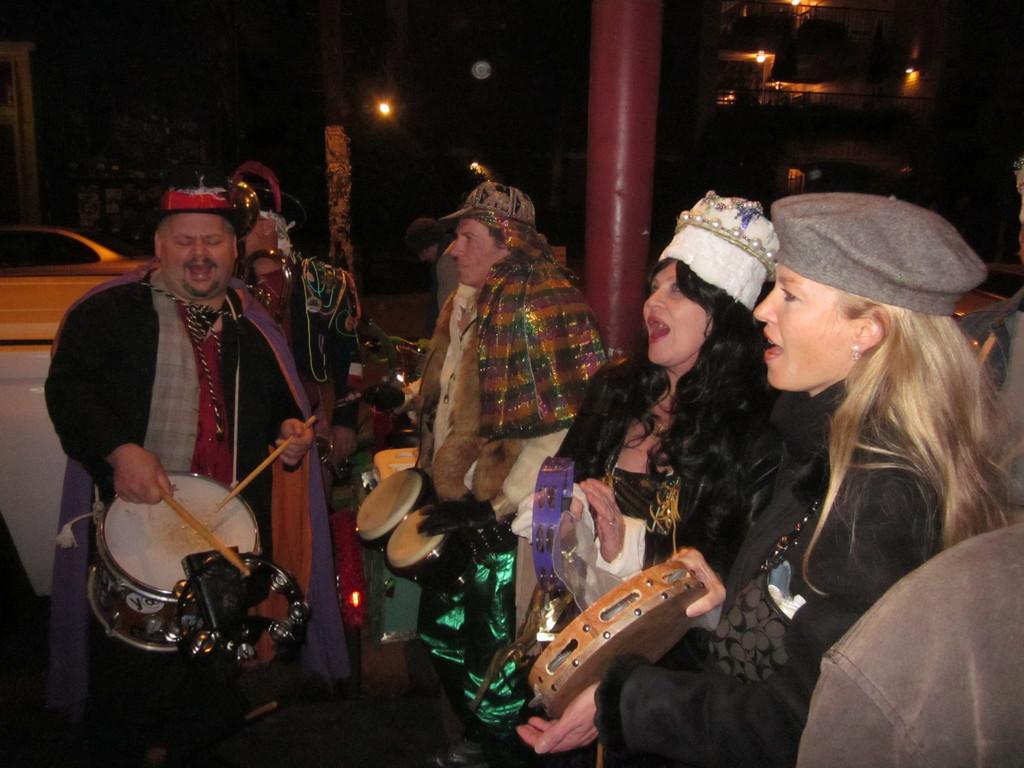Describe this image in one or two sentences. Background is very dark. This is a light. Here we can see a building. We can see few persons standing, singing and playing musical instruments in front of a picture. This is a car. 